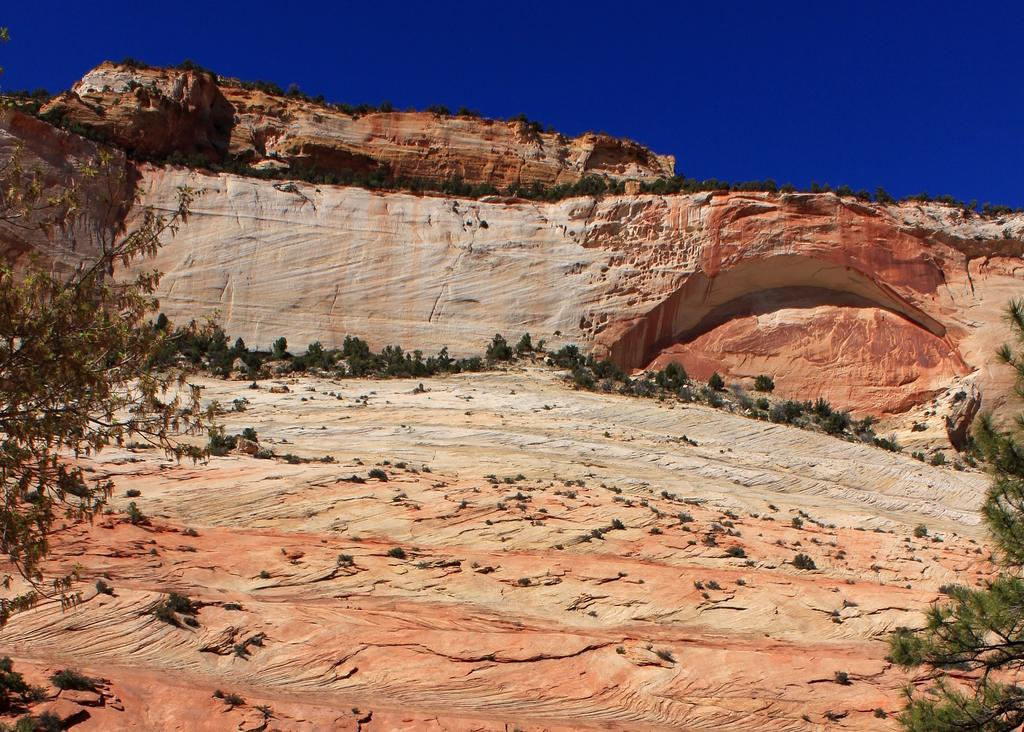What type of vegetation can be seen in the image? There are trees in the image. What type of geological feature is present in the image? There are rocky hills in the image. What is visible in the sky in the image? The sky is visible in the image. How many bricks can be seen in the image? There are no bricks present in the image. Can you describe the bee's behavior in the image? There are no bees present in the image. 